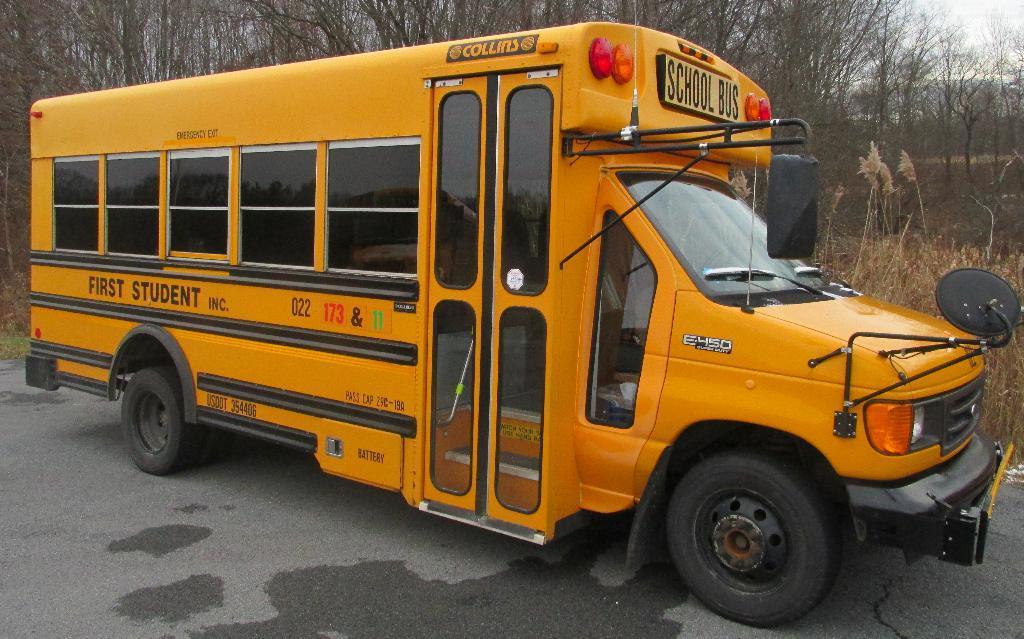Can you describe this image briefly? In this image, we can see a bus which is colored yellow. There are some plants on the right side of the image. In the background, we can see some trees. 